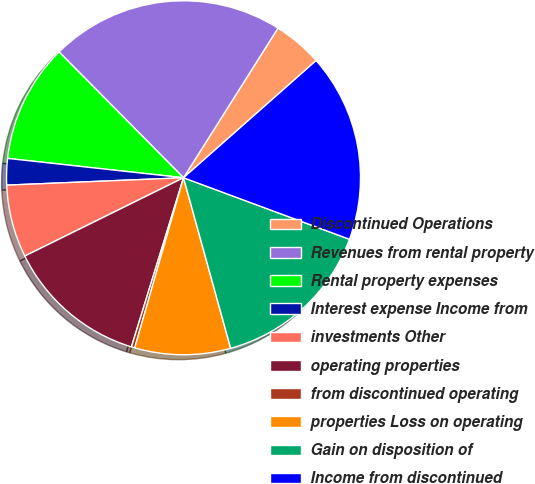<chart> <loc_0><loc_0><loc_500><loc_500><pie_chart><fcel>Discontinued Operations<fcel>Revenues from rental property<fcel>Rental property expenses<fcel>Interest expense Income from<fcel>investments Other<fcel>operating properties<fcel>from discontinued operating<fcel>properties Loss on operating<fcel>Gain on disposition of<fcel>Income from discontinued<nl><fcel>4.52%<fcel>21.38%<fcel>10.84%<fcel>2.41%<fcel>6.63%<fcel>12.95%<fcel>0.31%<fcel>8.74%<fcel>15.06%<fcel>17.17%<nl></chart> 